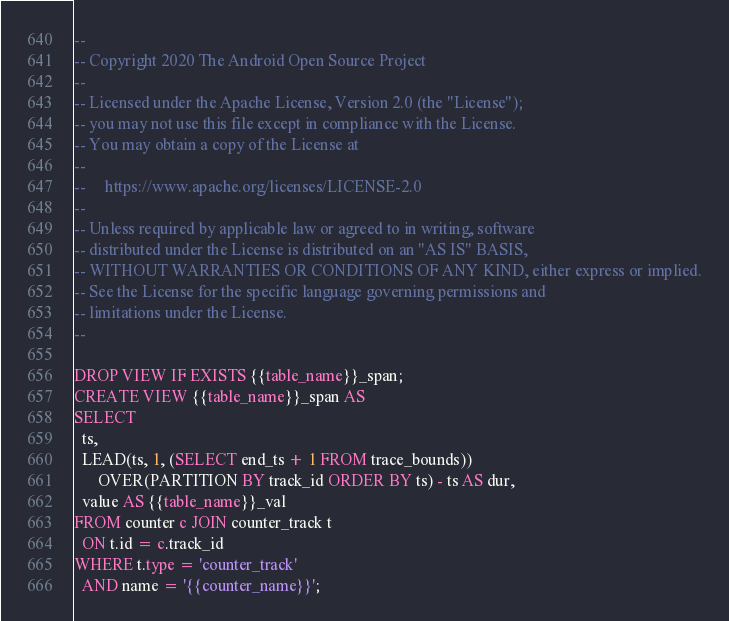<code> <loc_0><loc_0><loc_500><loc_500><_SQL_>--
-- Copyright 2020 The Android Open Source Project
--
-- Licensed under the Apache License, Version 2.0 (the "License");
-- you may not use this file except in compliance with the License.
-- You may obtain a copy of the License at
--
--     https://www.apache.org/licenses/LICENSE-2.0
--
-- Unless required by applicable law or agreed to in writing, software
-- distributed under the License is distributed on an "AS IS" BASIS,
-- WITHOUT WARRANTIES OR CONDITIONS OF ANY KIND, either express or implied.
-- See the License for the specific language governing permissions and
-- limitations under the License.
--

DROP VIEW IF EXISTS {{table_name}}_span;
CREATE VIEW {{table_name}}_span AS
SELECT
  ts,
  LEAD(ts, 1, (SELECT end_ts + 1 FROM trace_bounds))
      OVER(PARTITION BY track_id ORDER BY ts) - ts AS dur,
  value AS {{table_name}}_val
FROM counter c JOIN counter_track t
  ON t.id = c.track_id
WHERE t.type = 'counter_track'
  AND name = '{{counter_name}}';
</code> 